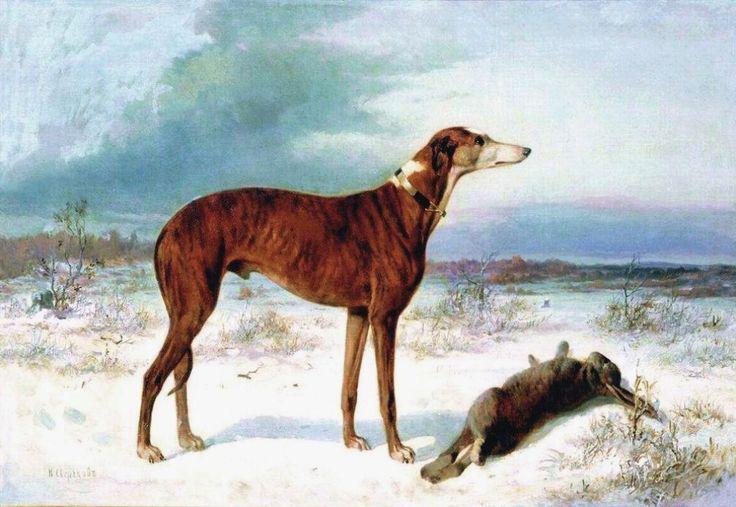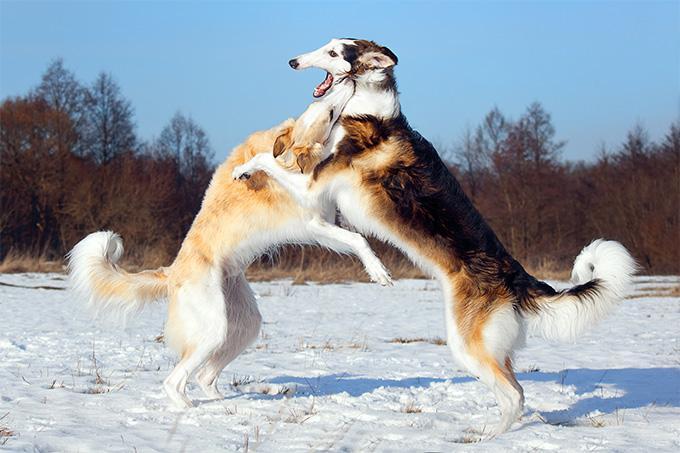The first image is the image on the left, the second image is the image on the right. For the images shown, is this caption "Two dogs are playing with each other in one image." true? Answer yes or no. Yes. 